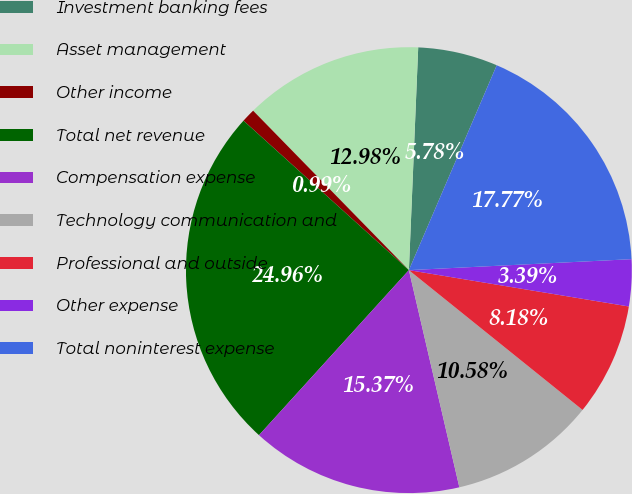<chart> <loc_0><loc_0><loc_500><loc_500><pie_chart><fcel>Investment banking fees<fcel>Asset management<fcel>Other income<fcel>Total net revenue<fcel>Compensation expense<fcel>Technology communication and<fcel>Professional and outside<fcel>Other expense<fcel>Total noninterest expense<nl><fcel>5.78%<fcel>12.98%<fcel>0.99%<fcel>24.96%<fcel>15.37%<fcel>10.58%<fcel>8.18%<fcel>3.39%<fcel>17.77%<nl></chart> 